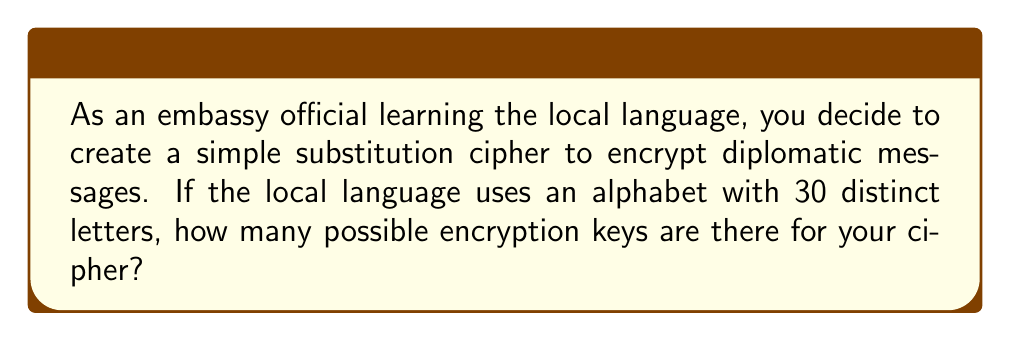Can you answer this question? Let's approach this step-by-step:

1) In a simple substitution cipher, each letter of the plaintext alphabet is replaced by a different letter of the ciphertext alphabet.

2) The number of possible keys is equal to the number of ways to arrange the letters of the alphabet.

3) This is a permutation problem. We are arranging all 30 letters, and the order matters.

4) The number of permutations of n distinct objects is given by n!

5) In this case, n = 30 (the number of letters in the alphabet)

6) Therefore, the number of possible encryption keys is:

   $$30! = 30 \times 29 \times 28 \times ... \times 3 \times 2 \times 1$$

7) This can be calculated:

   $$30! = 2.65252859812191058636308480000000 \times 10^{32}$$

8) This is an extremely large number, which is why simple substitution ciphers can be secure against brute-force attacks if the alphabet is large enough.
Answer: $30!$ or approximately $2.65 \times 10^{32}$ 